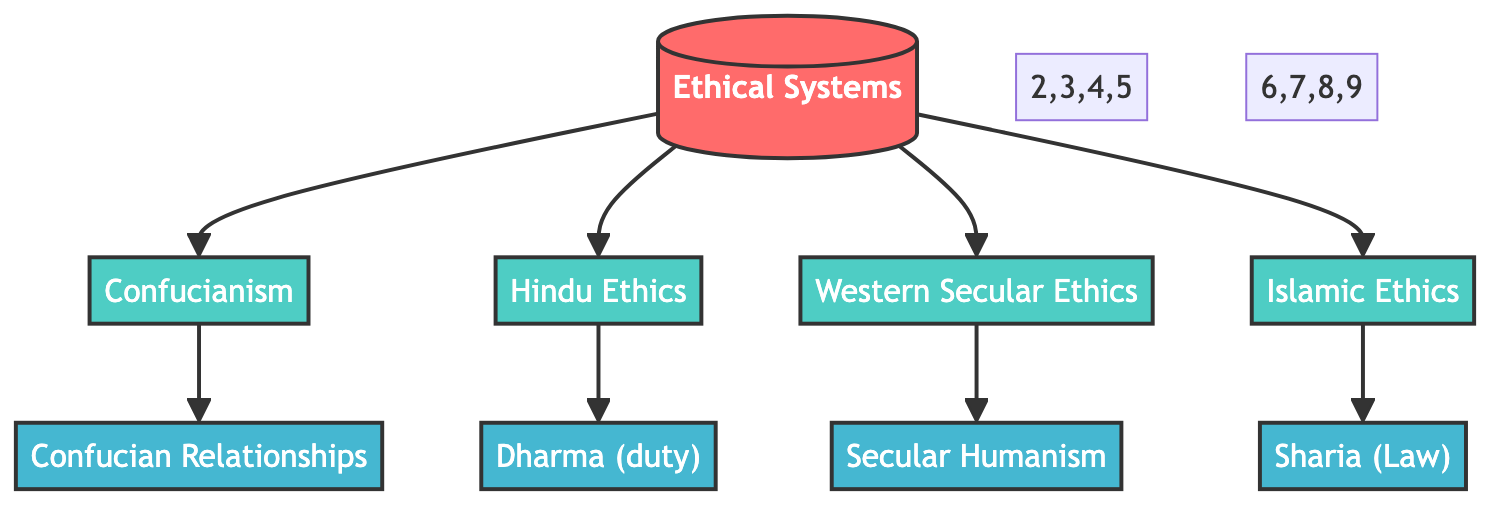What is the core node in the diagram? The core node is "Ethical Systems," which serves as the starting point of the diagram and connects to various ethical systems in different cultures.
Answer: Ethical Systems How many culture nodes are present? There are four culture nodes, which include Confucianism, Hindu Ethics, Western Secular Ethics, and Islamic Ethics.
Answer: 4 Which node is linked to "Dharma (duty)"? "Dharma (duty)" is linked to the "Hindu Ethics" node, showing its relevance within this ethical system.
Answer: Hindu Ethics Which attribute connects to Confucianism? The attribute that connects to Confucianism is "Confucian Relationships," illustrating an essential aspect of this ethical system.
Answer: Confucian Relationships What is the relationship between "Islamic Ethics" and "Sharia (Law)"? The relationship is a direct connection, where "Sharia (Law)" is an attribute linked to "Islamic Ethics," indicating its foundational role in this ethical system.
Answer: Sharia (Law) How many total nodes are there in the diagram? The total number of nodes is nine, comprising one core node, four culture nodes, and four attribute nodes.
Answer: 9 Which ethical system links to "Secular Humanism"? The ethical system linking to "Secular Humanism" is "Western Secular Ethics," indicating a significant aspect of this approach to ethics.
Answer: Western Secular Ethics What is the connection type between nodes? The connection type between nodes is a "link," denoting the relationships among the ethical systems and their attributes.
Answer: link Which culture node is the first to be shown in the diagram? The first culture node shown in the diagram is "Confucianism," which is directly connected to the core node "Ethical Systems."
Answer: Confucianism 